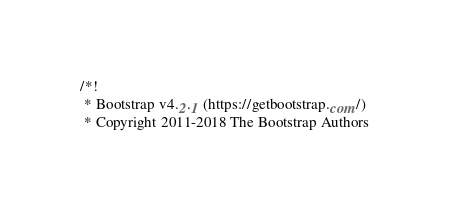<code> <loc_0><loc_0><loc_500><loc_500><_CSS_>/*!
 * Bootstrap v4.2.1 (https://getbootstrap.com/)
 * Copyright 2011-2018 The Bootstrap Authors</code> 